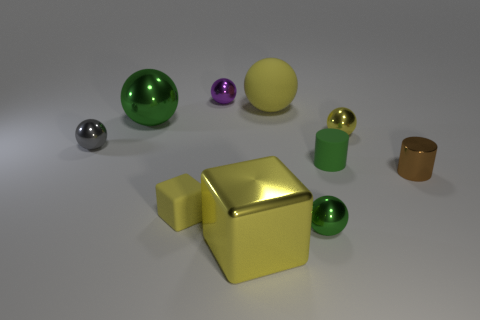How many other objects are there of the same color as the large block?
Offer a terse response. 3. What number of small green cylinders are the same material as the small yellow cube?
Make the answer very short. 1. What number of other objects are the same size as the gray metal sphere?
Offer a very short reply. 6. Are there any blocks that have the same size as the brown object?
Provide a succinct answer. Yes. Is the color of the big sphere on the left side of the big metallic block the same as the large rubber ball?
Give a very brief answer. No. What number of things are either small yellow objects or small purple metallic objects?
Give a very brief answer. 3. There is a green metal ball in front of the yellow shiny sphere; is it the same size as the small block?
Keep it short and to the point. Yes. What size is the object that is in front of the tiny green matte cylinder and to the left of the purple metal sphere?
Provide a short and direct response. Small. What number of other objects are there of the same shape as the gray thing?
Offer a very short reply. 5. How many other objects are the same material as the tiny yellow ball?
Provide a succinct answer. 6. 